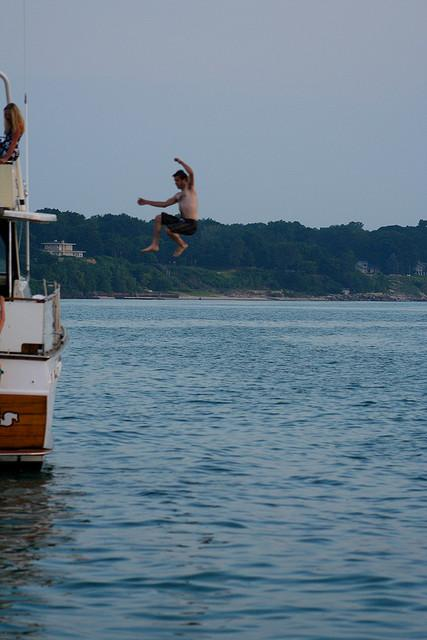Where does the man want to go? water 